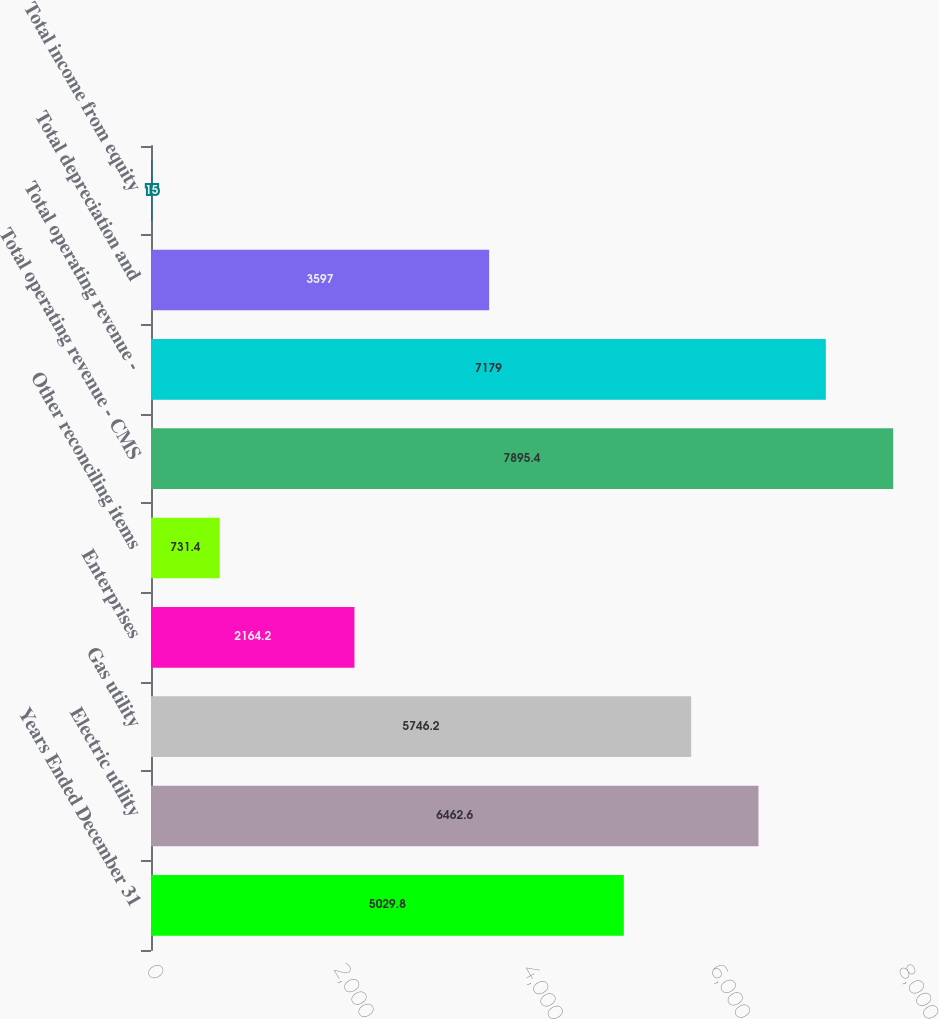<chart> <loc_0><loc_0><loc_500><loc_500><bar_chart><fcel>Years Ended December 31<fcel>Electric utility<fcel>Gas utility<fcel>Enterprises<fcel>Other reconciling items<fcel>Total operating revenue - CMS<fcel>Total operating revenue -<fcel>Total depreciation and<fcel>Total income from equity<nl><fcel>5029.8<fcel>6462.6<fcel>5746.2<fcel>2164.2<fcel>731.4<fcel>7895.4<fcel>7179<fcel>3597<fcel>15<nl></chart> 